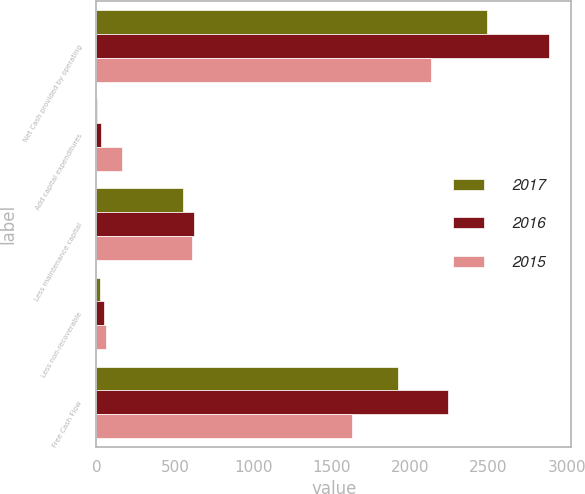Convert chart. <chart><loc_0><loc_0><loc_500><loc_500><stacked_bar_chart><ecel><fcel>Net Cash provided by operating<fcel>Add capital expenditures<fcel>Less maintenance capital<fcel>Less non-recoverable<fcel>Free Cash Flow<nl><fcel>2017<fcel>2489<fcel>6<fcel>551<fcel>23<fcel>1921<nl><fcel>2016<fcel>2884<fcel>29<fcel>624<fcel>45<fcel>2244<nl><fcel>2015<fcel>2134<fcel>165<fcel>611<fcel>60<fcel>1628<nl></chart> 